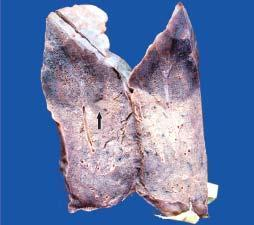what does the sectioned surface show with?
Answer the question using a single word or phrase. Base on the pleura 